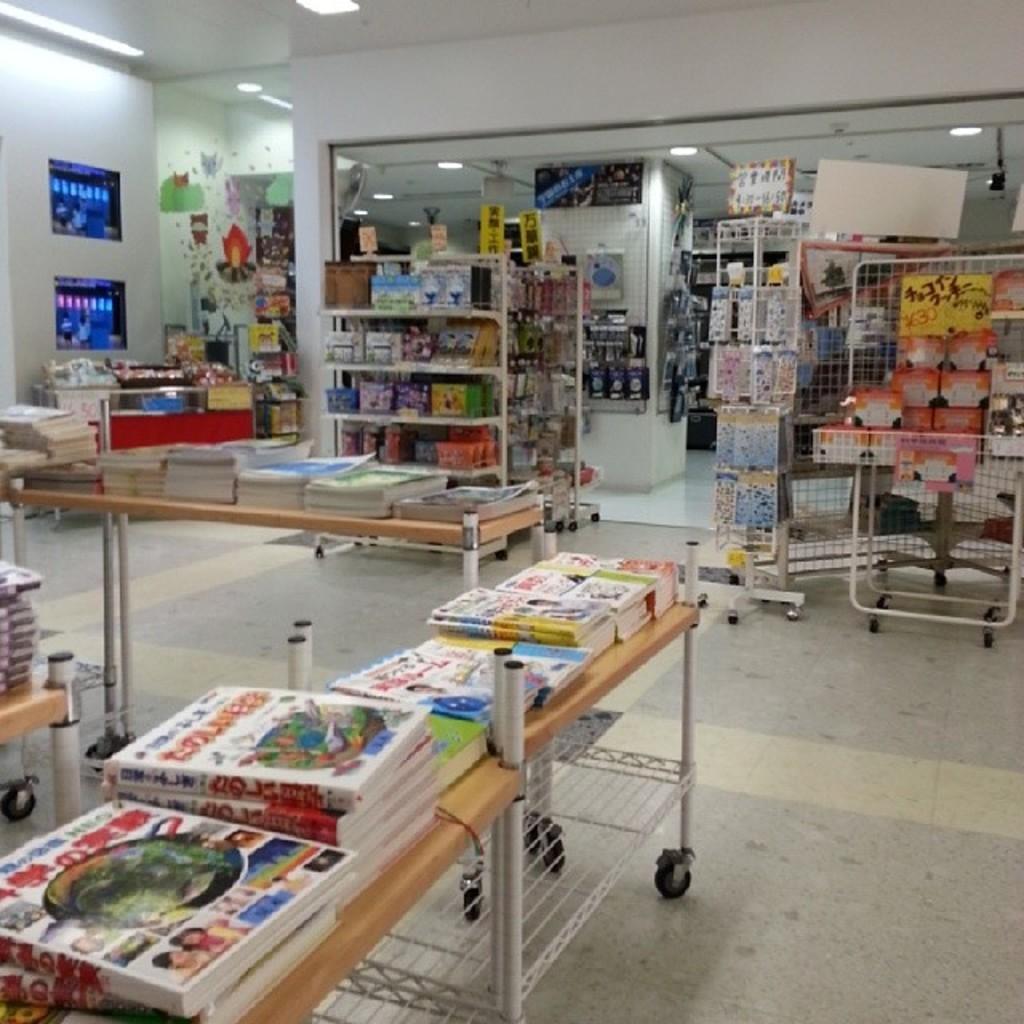Could you give a brief overview of what you see in this image? This picture is an inside view of a store. In this picture we can see the racks, wall. In the racks we can see the books. In the background of the image we can see the floor. At the top of the image we can see the lights, posters on the wall and roof. 